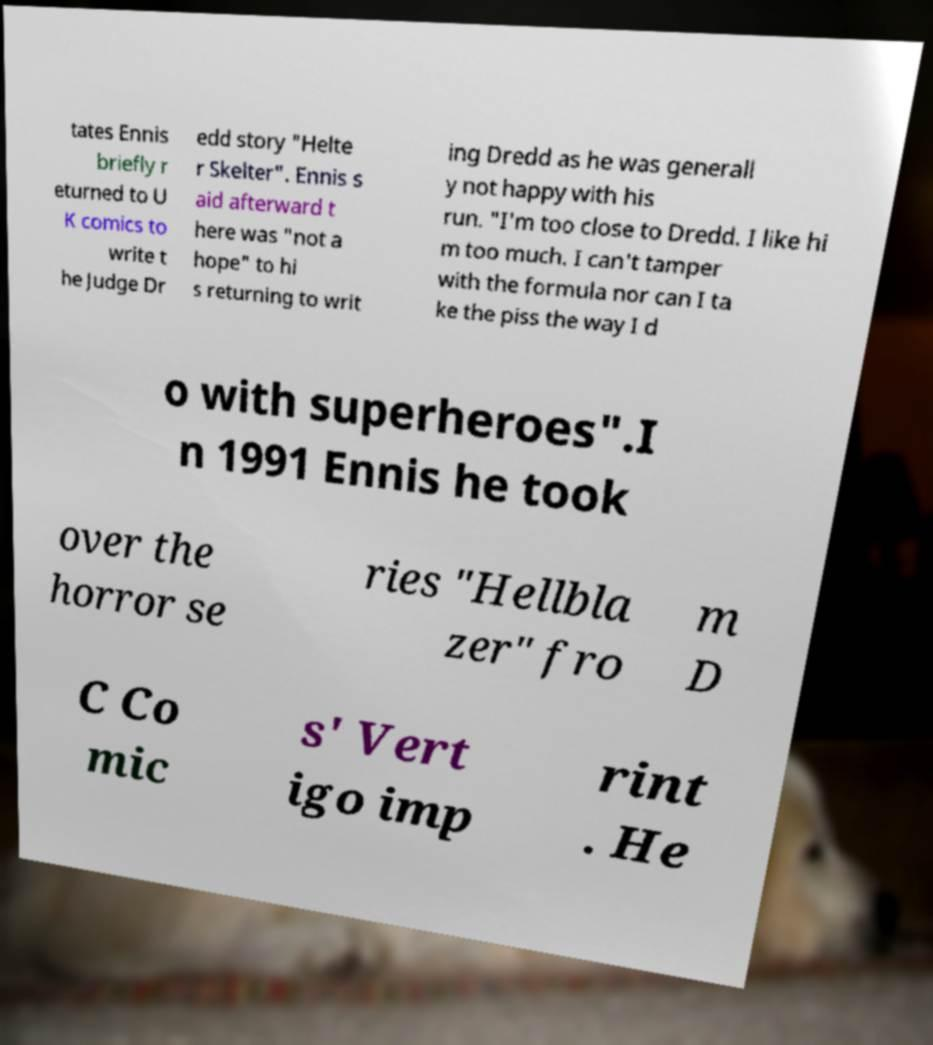Could you assist in decoding the text presented in this image and type it out clearly? tates Ennis briefly r eturned to U K comics to write t he Judge Dr edd story "Helte r Skelter". Ennis s aid afterward t here was "not a hope" to hi s returning to writ ing Dredd as he was generall y not happy with his run. "I'm too close to Dredd. I like hi m too much. I can't tamper with the formula nor can I ta ke the piss the way I d o with superheroes".I n 1991 Ennis he took over the horror se ries "Hellbla zer" fro m D C Co mic s' Vert igo imp rint . He 